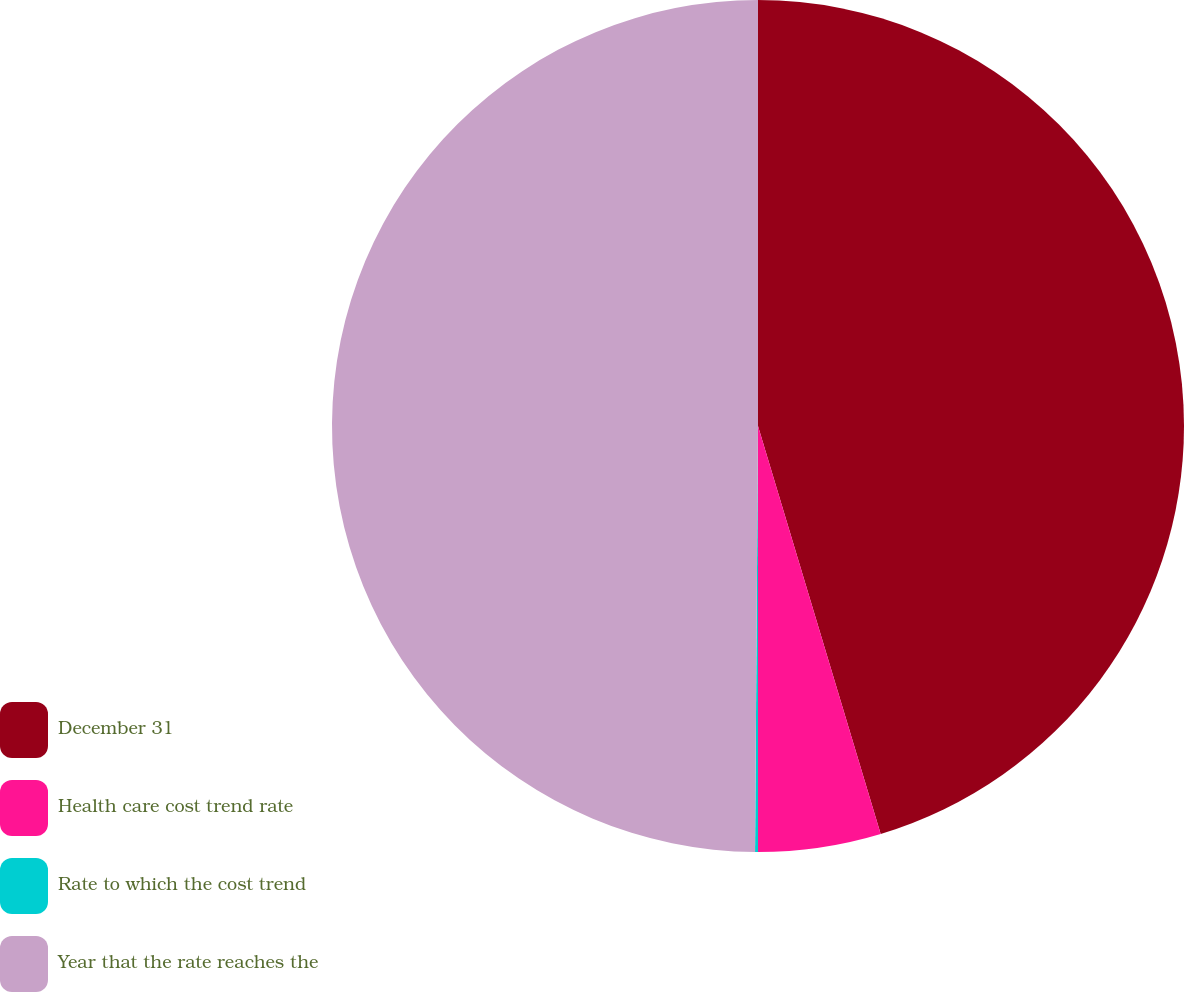<chart> <loc_0><loc_0><loc_500><loc_500><pie_chart><fcel>December 31<fcel>Health care cost trend rate<fcel>Rate to which the cost trend<fcel>Year that the rate reaches the<nl><fcel>45.35%<fcel>4.65%<fcel>0.11%<fcel>49.89%<nl></chart> 